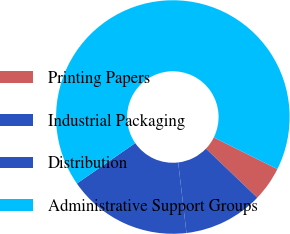<chart> <loc_0><loc_0><loc_500><loc_500><pie_chart><fcel>Printing Papers<fcel>Industrial Packaging<fcel>Distribution<fcel>Administrative Support Groups<nl><fcel>4.78%<fcel>11.0%<fcel>17.22%<fcel>66.99%<nl></chart> 